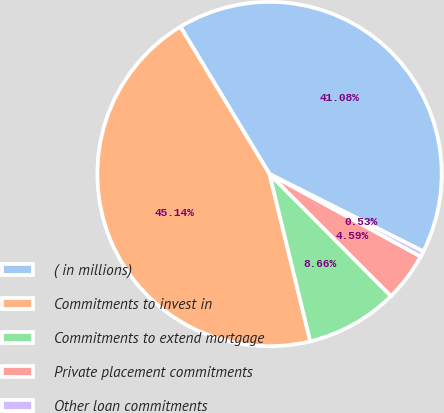Convert chart to OTSL. <chart><loc_0><loc_0><loc_500><loc_500><pie_chart><fcel>( in millions)<fcel>Commitments to invest in<fcel>Commitments to extend mortgage<fcel>Private placement commitments<fcel>Other loan commitments<nl><fcel>41.08%<fcel>45.14%<fcel>8.66%<fcel>4.59%<fcel>0.53%<nl></chart> 